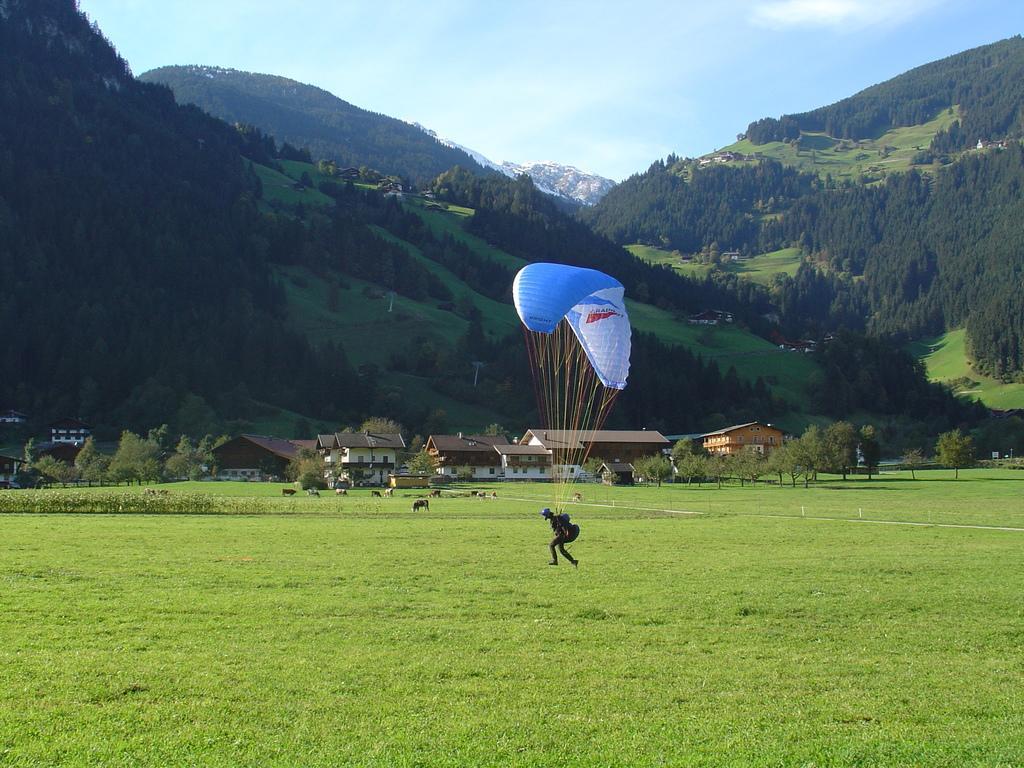Describe this image in one or two sentences. In this picture I can see a person and a parachute. In the background I can see buildings, trees, mountains and the sky. Here I can see grass and animals on the ground. 